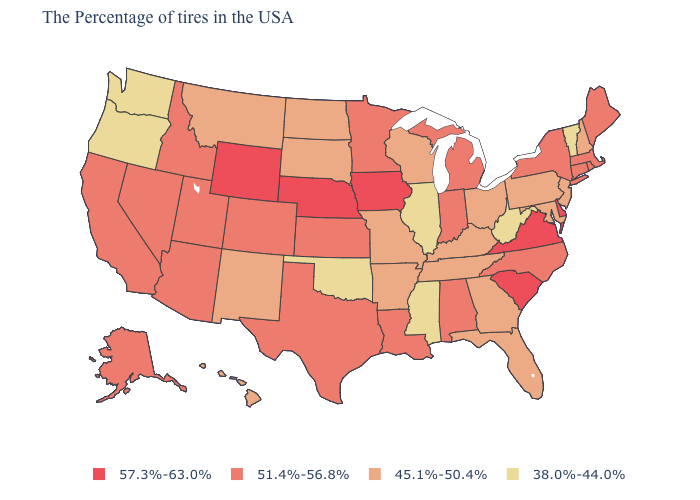What is the highest value in states that border Wisconsin?
Keep it brief. 57.3%-63.0%. What is the value of Arkansas?
Quick response, please. 45.1%-50.4%. What is the value of Wisconsin?
Short answer required. 45.1%-50.4%. Name the states that have a value in the range 45.1%-50.4%?
Short answer required. New Hampshire, New Jersey, Maryland, Pennsylvania, Ohio, Florida, Georgia, Kentucky, Tennessee, Wisconsin, Missouri, Arkansas, South Dakota, North Dakota, New Mexico, Montana, Hawaii. What is the value of North Carolina?
Short answer required. 51.4%-56.8%. Name the states that have a value in the range 51.4%-56.8%?
Give a very brief answer. Maine, Massachusetts, Rhode Island, Connecticut, New York, North Carolina, Michigan, Indiana, Alabama, Louisiana, Minnesota, Kansas, Texas, Colorado, Utah, Arizona, Idaho, Nevada, California, Alaska. Name the states that have a value in the range 51.4%-56.8%?
Keep it brief. Maine, Massachusetts, Rhode Island, Connecticut, New York, North Carolina, Michigan, Indiana, Alabama, Louisiana, Minnesota, Kansas, Texas, Colorado, Utah, Arizona, Idaho, Nevada, California, Alaska. Does Illinois have the lowest value in the USA?
Quick response, please. Yes. What is the value of Maine?
Give a very brief answer. 51.4%-56.8%. Name the states that have a value in the range 45.1%-50.4%?
Answer briefly. New Hampshire, New Jersey, Maryland, Pennsylvania, Ohio, Florida, Georgia, Kentucky, Tennessee, Wisconsin, Missouri, Arkansas, South Dakota, North Dakota, New Mexico, Montana, Hawaii. Which states hav the highest value in the West?
Quick response, please. Wyoming. Name the states that have a value in the range 57.3%-63.0%?
Keep it brief. Delaware, Virginia, South Carolina, Iowa, Nebraska, Wyoming. Does Wyoming have the highest value in the West?
Be succinct. Yes. Is the legend a continuous bar?
Short answer required. No. Name the states that have a value in the range 51.4%-56.8%?
Be succinct. Maine, Massachusetts, Rhode Island, Connecticut, New York, North Carolina, Michigan, Indiana, Alabama, Louisiana, Minnesota, Kansas, Texas, Colorado, Utah, Arizona, Idaho, Nevada, California, Alaska. 